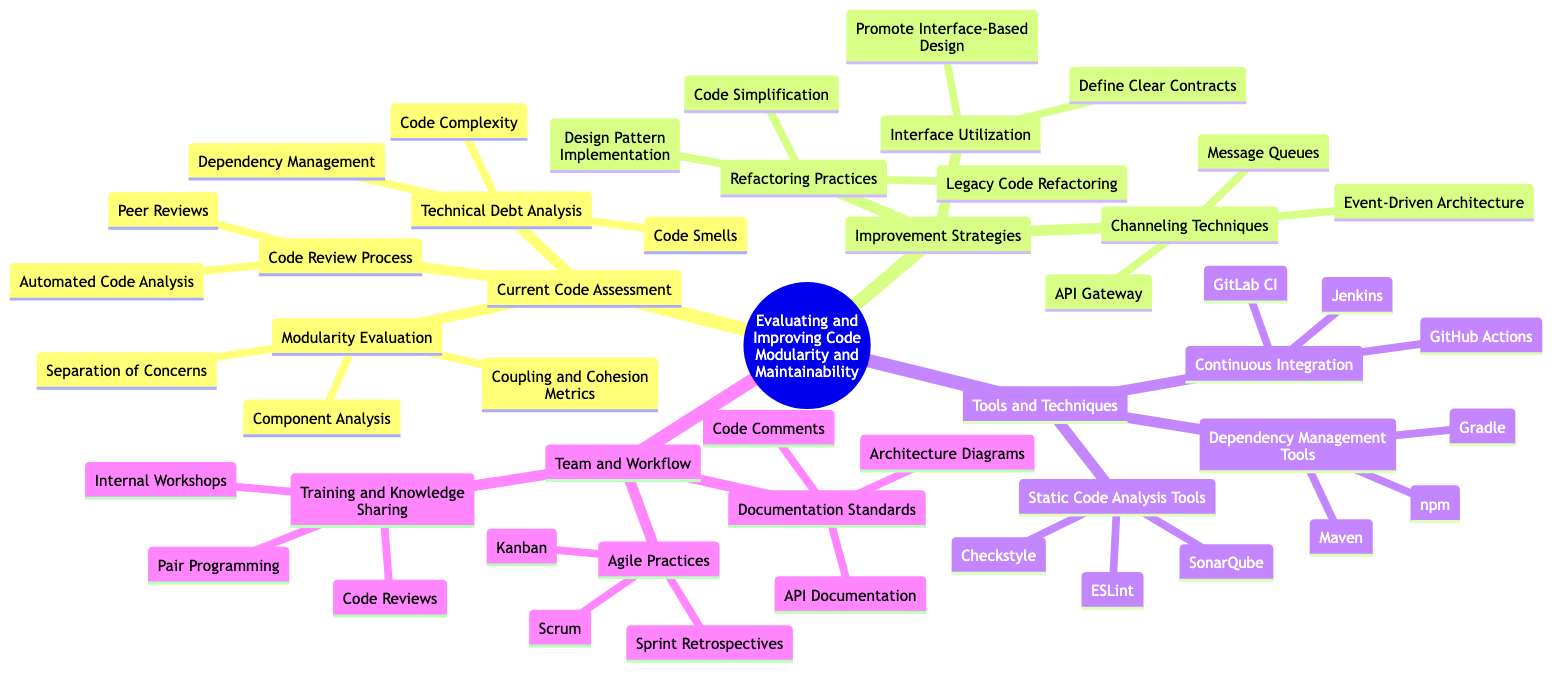What is the main topic of the diagram? The main topic is clearly labeled at the center of the diagram, reading "Evaluating and Improving Code Modularity and Maintainability". This serves as the umbrella under which all other subtopics are categorized.
Answer: Evaluating and Improving Code Modularity and Maintainability How many subtopics are there under the main topic? Counting the first layer of nodes extending from the main topic, there are four subtopics: "Current Code Assessment," "Improvement Strategies," "Tools and Techniques," and "Team and Workflow". This is straightforward as each subtopic is distinctly listed.
Answer: Four What are the elements under "Improvement Strategies"? Under "Improvement Strategies", there are three elements listed: "Refactoring Practices," "Interface Utilization," and "Channeling Techniques". By looking at that branch of the mind map, it's easy to see the distinct elements grouped together.
Answer: Refactoring Practices, Interface Utilization, Channeling Techniques Which tools are listed under "Static Code Analysis Tools"? The tools mentioned under "Static Code Analysis Tools" include "SonarQube," "ESLint," and "Checkstyle". These are explicitly listed as sub-elements of the "Tools and Techniques" subtopic.
Answer: SonarQube, ESLint, Checkstyle What is the connection between "Technical Debt Analysis" and "Code Complexity"? "Technical Debt Analysis" is a parent node, and "Code Complexity" is one of its child elements. This means that "Code Complexity" is a part of the broader category of "Technical Debt Analysis", indicating that it is one aspect of assessing technical debt in the code.
Answer: Code Complexity is a child element of Technical Debt Analysis How many specific practices fall under "Agile Practices"? There are three specific practices listed under "Agile Practices", which are "Scrum," "Kanban," and "Sprint Retrospectives". Thus, by examining the "Team and Workflow" branch, you can determine the count easily by recognizing these elements.
Answer: Three What is the primary focus of "Interface Utilization" strategies? The strategies listed under "Interface Utilization" include "Define Clear Contracts" and "Promote Interface-Based Design". Understanding these strategies suggests that the primary focus is on improving design clarity and modularity through interfaces.
Answer: Define Clear Contracts, Promote Interface-Based Design How do "Continuous Integration" tools contribute to code maintainability? The list shows tools like "Jenkins," "GitHub Actions," and "GitLab CI" under "Continuous Integration". This indicates that these tools facilitate regular integration of code, which helps in identifying defects early and improving maintainability.
Answer: Jenkins, GitHub Actions, GitLab CI What is a technique mentioned under "Channeling Techniques"? One of the specific techniques mentioned under "Channeling Techniques" is "Event-Driven Architecture". This method focuses on creating a responsive system that enhances modularity and maintainability.
Answer: Event-Driven Architecture 